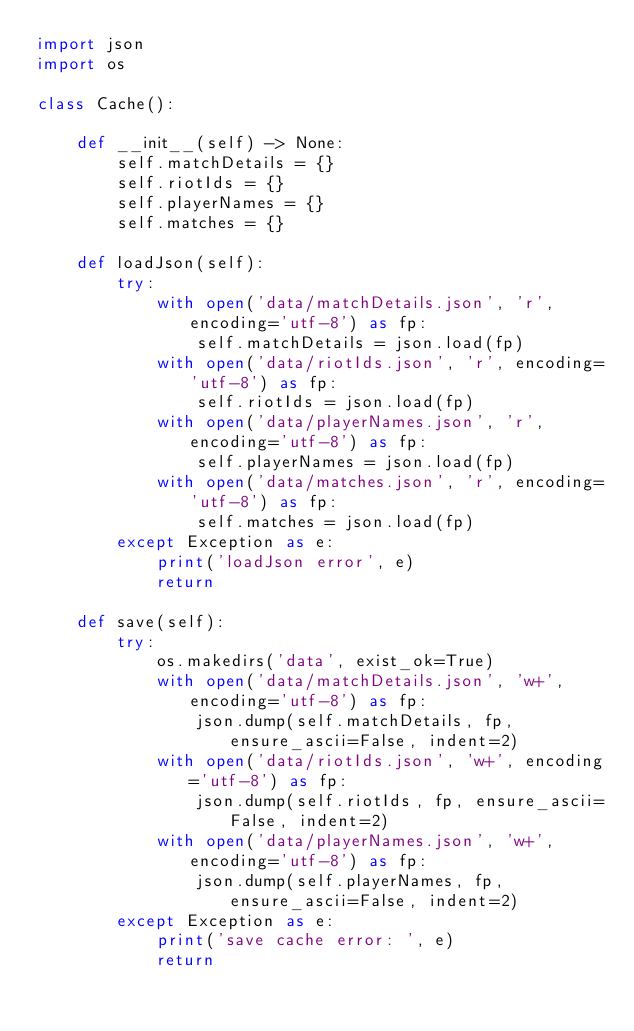Convert code to text. <code><loc_0><loc_0><loc_500><loc_500><_Python_>import json
import os

class Cache():
    
    def __init__(self) -> None:
        self.matchDetails = {}
        self.riotIds = {}
        self.playerNames = {}
        self.matches = {}

    def loadJson(self):
        try:
            with open('data/matchDetails.json', 'r', encoding='utf-8') as fp:
                self.matchDetails = json.load(fp)
            with open('data/riotIds.json', 'r', encoding='utf-8') as fp:
                self.riotIds = json.load(fp)
            with open('data/playerNames.json', 'r', encoding='utf-8') as fp:
                self.playerNames = json.load(fp)
            with open('data/matches.json', 'r', encoding='utf-8') as fp:
                self.matches = json.load(fp)
        except Exception as e:
            print('loadJson error', e)
            return

    def save(self):
        try:
            os.makedirs('data', exist_ok=True)
            with open('data/matchDetails.json', 'w+', encoding='utf-8') as fp:
                json.dump(self.matchDetails, fp, ensure_ascii=False, indent=2)
            with open('data/riotIds.json', 'w+', encoding='utf-8') as fp:
                json.dump(self.riotIds, fp, ensure_ascii=False, indent=2)
            with open('data/playerNames.json', 'w+', encoding='utf-8') as fp:
                json.dump(self.playerNames, fp, ensure_ascii=False, indent=2)
        except Exception as e:
            print('save cache error: ', e)
            return</code> 